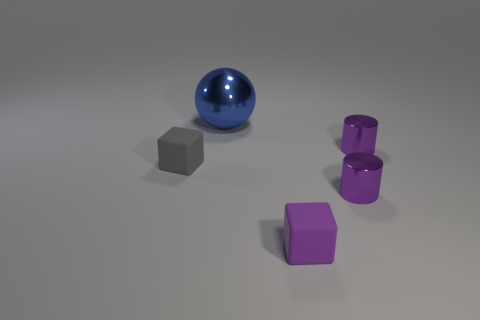Add 1 large spheres. How many objects exist? 6 Subtract all cylinders. How many objects are left? 3 Subtract all tiny cyan objects. Subtract all metal cylinders. How many objects are left? 3 Add 5 tiny things. How many tiny things are left? 9 Add 5 tiny gray things. How many tiny gray things exist? 6 Subtract 0 blue cylinders. How many objects are left? 5 